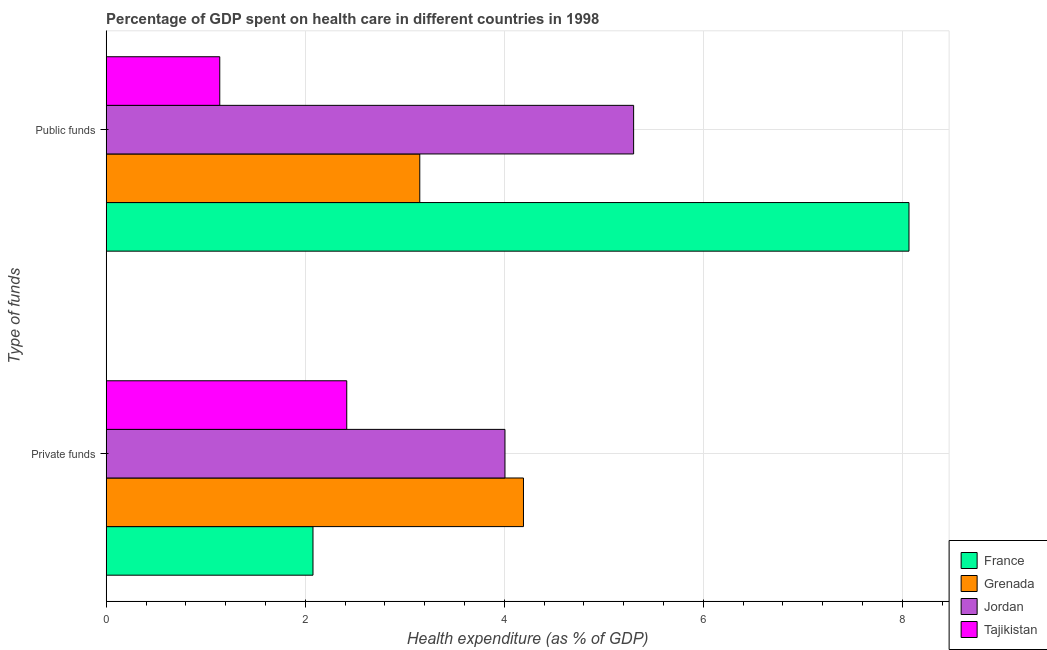How many different coloured bars are there?
Give a very brief answer. 4. How many groups of bars are there?
Keep it short and to the point. 2. Are the number of bars per tick equal to the number of legend labels?
Provide a short and direct response. Yes. Are the number of bars on each tick of the Y-axis equal?
Give a very brief answer. Yes. How many bars are there on the 2nd tick from the top?
Ensure brevity in your answer.  4. What is the label of the 2nd group of bars from the top?
Provide a succinct answer. Private funds. What is the amount of public funds spent in healthcare in Tajikistan?
Give a very brief answer. 1.14. Across all countries, what is the maximum amount of private funds spent in healthcare?
Your response must be concise. 4.19. Across all countries, what is the minimum amount of public funds spent in healthcare?
Your response must be concise. 1.14. In which country was the amount of private funds spent in healthcare maximum?
Keep it short and to the point. Grenada. In which country was the amount of public funds spent in healthcare minimum?
Offer a terse response. Tajikistan. What is the total amount of public funds spent in healthcare in the graph?
Offer a very short reply. 17.66. What is the difference between the amount of private funds spent in healthcare in Grenada and that in Jordan?
Your answer should be compact. 0.19. What is the difference between the amount of private funds spent in healthcare in Jordan and the amount of public funds spent in healthcare in Tajikistan?
Give a very brief answer. 2.87. What is the average amount of private funds spent in healthcare per country?
Provide a short and direct response. 3.17. What is the difference between the amount of public funds spent in healthcare and amount of private funds spent in healthcare in Jordan?
Keep it short and to the point. 1.29. In how many countries, is the amount of public funds spent in healthcare greater than 6.8 %?
Give a very brief answer. 1. What is the ratio of the amount of private funds spent in healthcare in Jordan to that in France?
Provide a succinct answer. 1.93. Is the amount of private funds spent in healthcare in France less than that in Jordan?
Give a very brief answer. Yes. In how many countries, is the amount of private funds spent in healthcare greater than the average amount of private funds spent in healthcare taken over all countries?
Ensure brevity in your answer.  2. What does the 3rd bar from the bottom in Public funds represents?
Your response must be concise. Jordan. How many bars are there?
Offer a very short reply. 8. Are all the bars in the graph horizontal?
Your answer should be very brief. Yes. Does the graph contain grids?
Your answer should be compact. Yes. How are the legend labels stacked?
Provide a succinct answer. Vertical. What is the title of the graph?
Provide a succinct answer. Percentage of GDP spent on health care in different countries in 1998. Does "Puerto Rico" appear as one of the legend labels in the graph?
Your answer should be compact. No. What is the label or title of the X-axis?
Your answer should be very brief. Health expenditure (as % of GDP). What is the label or title of the Y-axis?
Your response must be concise. Type of funds. What is the Health expenditure (as % of GDP) in France in Private funds?
Ensure brevity in your answer.  2.08. What is the Health expenditure (as % of GDP) of Grenada in Private funds?
Ensure brevity in your answer.  4.19. What is the Health expenditure (as % of GDP) of Jordan in Private funds?
Provide a succinct answer. 4.01. What is the Health expenditure (as % of GDP) in Tajikistan in Private funds?
Offer a terse response. 2.42. What is the Health expenditure (as % of GDP) of France in Public funds?
Ensure brevity in your answer.  8.07. What is the Health expenditure (as % of GDP) of Grenada in Public funds?
Your response must be concise. 3.15. What is the Health expenditure (as % of GDP) of Jordan in Public funds?
Your answer should be compact. 5.3. What is the Health expenditure (as % of GDP) of Tajikistan in Public funds?
Provide a short and direct response. 1.14. Across all Type of funds, what is the maximum Health expenditure (as % of GDP) in France?
Your answer should be very brief. 8.07. Across all Type of funds, what is the maximum Health expenditure (as % of GDP) in Grenada?
Your response must be concise. 4.19. Across all Type of funds, what is the maximum Health expenditure (as % of GDP) in Jordan?
Your answer should be very brief. 5.3. Across all Type of funds, what is the maximum Health expenditure (as % of GDP) in Tajikistan?
Offer a terse response. 2.42. Across all Type of funds, what is the minimum Health expenditure (as % of GDP) in France?
Provide a short and direct response. 2.08. Across all Type of funds, what is the minimum Health expenditure (as % of GDP) in Grenada?
Offer a very short reply. 3.15. Across all Type of funds, what is the minimum Health expenditure (as % of GDP) in Jordan?
Offer a terse response. 4.01. Across all Type of funds, what is the minimum Health expenditure (as % of GDP) of Tajikistan?
Offer a terse response. 1.14. What is the total Health expenditure (as % of GDP) of France in the graph?
Your answer should be very brief. 10.15. What is the total Health expenditure (as % of GDP) in Grenada in the graph?
Provide a succinct answer. 7.34. What is the total Health expenditure (as % of GDP) of Jordan in the graph?
Provide a short and direct response. 9.31. What is the total Health expenditure (as % of GDP) of Tajikistan in the graph?
Give a very brief answer. 3.56. What is the difference between the Health expenditure (as % of GDP) of France in Private funds and that in Public funds?
Keep it short and to the point. -5.99. What is the difference between the Health expenditure (as % of GDP) in Grenada in Private funds and that in Public funds?
Give a very brief answer. 1.04. What is the difference between the Health expenditure (as % of GDP) in Jordan in Private funds and that in Public funds?
Provide a short and direct response. -1.29. What is the difference between the Health expenditure (as % of GDP) in Tajikistan in Private funds and that in Public funds?
Offer a terse response. 1.28. What is the difference between the Health expenditure (as % of GDP) in France in Private funds and the Health expenditure (as % of GDP) in Grenada in Public funds?
Make the answer very short. -1.07. What is the difference between the Health expenditure (as % of GDP) of France in Private funds and the Health expenditure (as % of GDP) of Jordan in Public funds?
Your answer should be very brief. -3.22. What is the difference between the Health expenditure (as % of GDP) of France in Private funds and the Health expenditure (as % of GDP) of Tajikistan in Public funds?
Your answer should be compact. 0.94. What is the difference between the Health expenditure (as % of GDP) of Grenada in Private funds and the Health expenditure (as % of GDP) of Jordan in Public funds?
Your response must be concise. -1.11. What is the difference between the Health expenditure (as % of GDP) in Grenada in Private funds and the Health expenditure (as % of GDP) in Tajikistan in Public funds?
Your answer should be very brief. 3.05. What is the difference between the Health expenditure (as % of GDP) of Jordan in Private funds and the Health expenditure (as % of GDP) of Tajikistan in Public funds?
Offer a very short reply. 2.87. What is the average Health expenditure (as % of GDP) in France per Type of funds?
Your answer should be very brief. 5.07. What is the average Health expenditure (as % of GDP) of Grenada per Type of funds?
Make the answer very short. 3.67. What is the average Health expenditure (as % of GDP) in Jordan per Type of funds?
Provide a short and direct response. 4.65. What is the average Health expenditure (as % of GDP) of Tajikistan per Type of funds?
Give a very brief answer. 1.78. What is the difference between the Health expenditure (as % of GDP) of France and Health expenditure (as % of GDP) of Grenada in Private funds?
Make the answer very short. -2.12. What is the difference between the Health expenditure (as % of GDP) of France and Health expenditure (as % of GDP) of Jordan in Private funds?
Provide a short and direct response. -1.93. What is the difference between the Health expenditure (as % of GDP) in France and Health expenditure (as % of GDP) in Tajikistan in Private funds?
Ensure brevity in your answer.  -0.34. What is the difference between the Health expenditure (as % of GDP) in Grenada and Health expenditure (as % of GDP) in Jordan in Private funds?
Give a very brief answer. 0.19. What is the difference between the Health expenditure (as % of GDP) of Grenada and Health expenditure (as % of GDP) of Tajikistan in Private funds?
Your answer should be compact. 1.78. What is the difference between the Health expenditure (as % of GDP) of Jordan and Health expenditure (as % of GDP) of Tajikistan in Private funds?
Give a very brief answer. 1.59. What is the difference between the Health expenditure (as % of GDP) of France and Health expenditure (as % of GDP) of Grenada in Public funds?
Your answer should be very brief. 4.92. What is the difference between the Health expenditure (as % of GDP) in France and Health expenditure (as % of GDP) in Jordan in Public funds?
Your answer should be very brief. 2.77. What is the difference between the Health expenditure (as % of GDP) of France and Health expenditure (as % of GDP) of Tajikistan in Public funds?
Your response must be concise. 6.93. What is the difference between the Health expenditure (as % of GDP) of Grenada and Health expenditure (as % of GDP) of Jordan in Public funds?
Give a very brief answer. -2.15. What is the difference between the Health expenditure (as % of GDP) of Grenada and Health expenditure (as % of GDP) of Tajikistan in Public funds?
Your answer should be compact. 2.01. What is the difference between the Health expenditure (as % of GDP) of Jordan and Health expenditure (as % of GDP) of Tajikistan in Public funds?
Keep it short and to the point. 4.16. What is the ratio of the Health expenditure (as % of GDP) of France in Private funds to that in Public funds?
Your response must be concise. 0.26. What is the ratio of the Health expenditure (as % of GDP) in Grenada in Private funds to that in Public funds?
Your answer should be compact. 1.33. What is the ratio of the Health expenditure (as % of GDP) of Jordan in Private funds to that in Public funds?
Your answer should be very brief. 0.76. What is the ratio of the Health expenditure (as % of GDP) in Tajikistan in Private funds to that in Public funds?
Ensure brevity in your answer.  2.12. What is the difference between the highest and the second highest Health expenditure (as % of GDP) in France?
Your response must be concise. 5.99. What is the difference between the highest and the second highest Health expenditure (as % of GDP) of Grenada?
Offer a very short reply. 1.04. What is the difference between the highest and the second highest Health expenditure (as % of GDP) in Jordan?
Your answer should be very brief. 1.29. What is the difference between the highest and the second highest Health expenditure (as % of GDP) in Tajikistan?
Your response must be concise. 1.28. What is the difference between the highest and the lowest Health expenditure (as % of GDP) of France?
Offer a very short reply. 5.99. What is the difference between the highest and the lowest Health expenditure (as % of GDP) in Grenada?
Provide a short and direct response. 1.04. What is the difference between the highest and the lowest Health expenditure (as % of GDP) of Jordan?
Your answer should be compact. 1.29. What is the difference between the highest and the lowest Health expenditure (as % of GDP) of Tajikistan?
Provide a short and direct response. 1.28. 